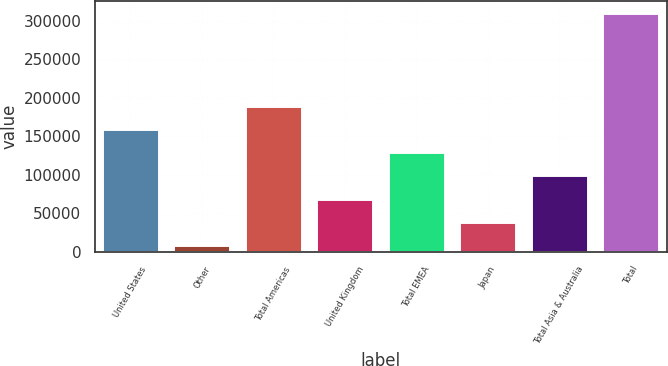<chart> <loc_0><loc_0><loc_500><loc_500><bar_chart><fcel>United States<fcel>Other<fcel>Total Americas<fcel>United Kingdom<fcel>Total EMEA<fcel>Japan<fcel>Total Asia & Australia<fcel>Total<nl><fcel>159772<fcel>8847<fcel>189958<fcel>69217.2<fcel>129587<fcel>39032.1<fcel>99402.3<fcel>310698<nl></chart> 